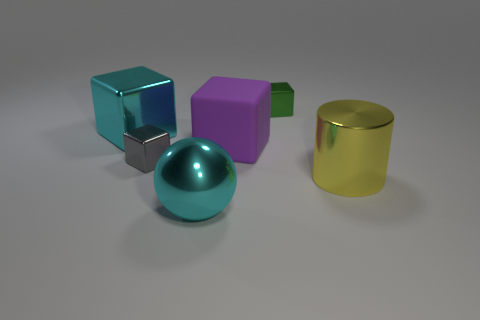What number of matte things are large purple cubes or small objects?
Give a very brief answer. 1. What is the shape of the large metal object that is the same color as the metal sphere?
Offer a terse response. Cube. Do the large block that is in front of the cyan metal block and the large cylinder have the same color?
Give a very brief answer. No. The thing in front of the metallic thing that is on the right side of the green metal block is what shape?
Give a very brief answer. Sphere. How many things are tiny metallic things that are on the left side of the small green metal thing or objects in front of the tiny gray block?
Your answer should be very brief. 3. There is a green thing that is made of the same material as the large cyan ball; what is its shape?
Offer a very short reply. Cube. Are there any other things that are the same color as the metal cylinder?
Provide a succinct answer. No. Are there the same number of big brown spheres and big metallic cylinders?
Your answer should be compact. No. What is the material of the small green object that is the same shape as the small gray metal thing?
Your response must be concise. Metal. How many other things are there of the same size as the rubber object?
Your answer should be compact. 3. 